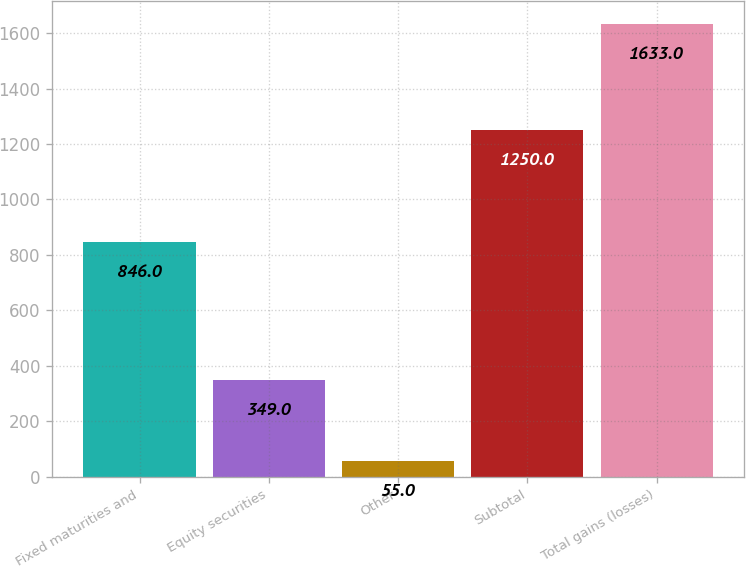Convert chart. <chart><loc_0><loc_0><loc_500><loc_500><bar_chart><fcel>Fixed maturities and<fcel>Equity securities<fcel>Other<fcel>Subtotal<fcel>Total gains (losses)<nl><fcel>846<fcel>349<fcel>55<fcel>1250<fcel>1633<nl></chart> 